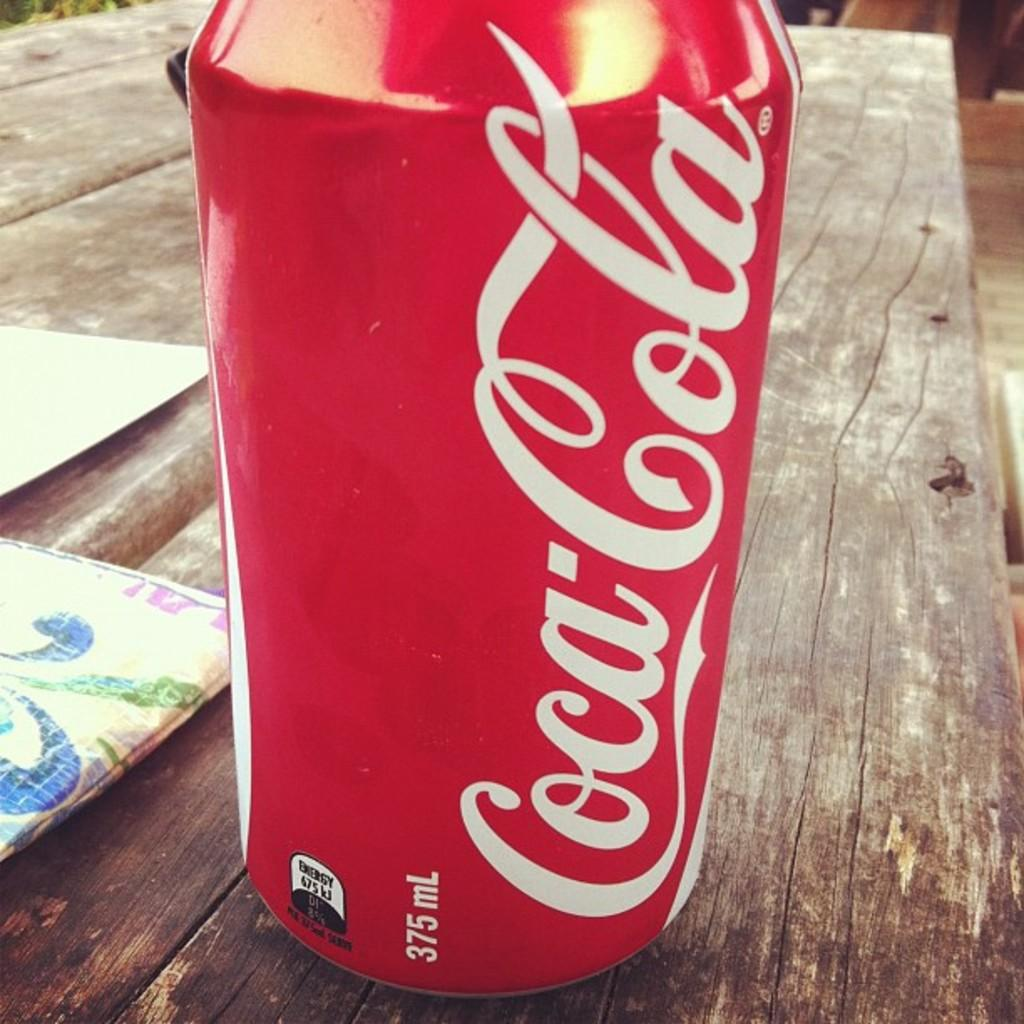<image>
Offer a succinct explanation of the picture presented. A can of Coca-Cola, which has a volume of 375 mL, sits atop a wooden table. 